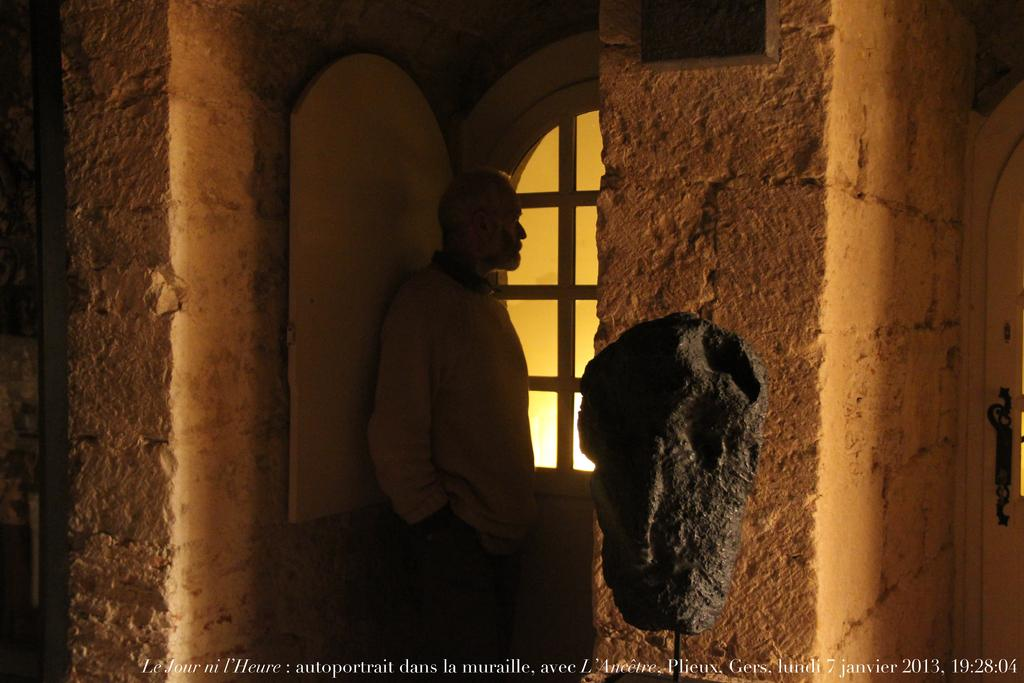What is the main subject in the image? There is a person standing in the image. What architectural features can be seen in the image? There is a window and a door in the image. What is the color of the walls in the image? The walls are brown in color. What is the color of the black colored object in the image? The black colored object is black in color. Where is the door located in the image? There is a door on the right side of the image. Can you tell me how many times the person swings their arms in the image? There is no indication of the person swinging their arms in the image. What type of angle is the person standing at in the image? The image does not provide information about the angle at which the person is standing. 